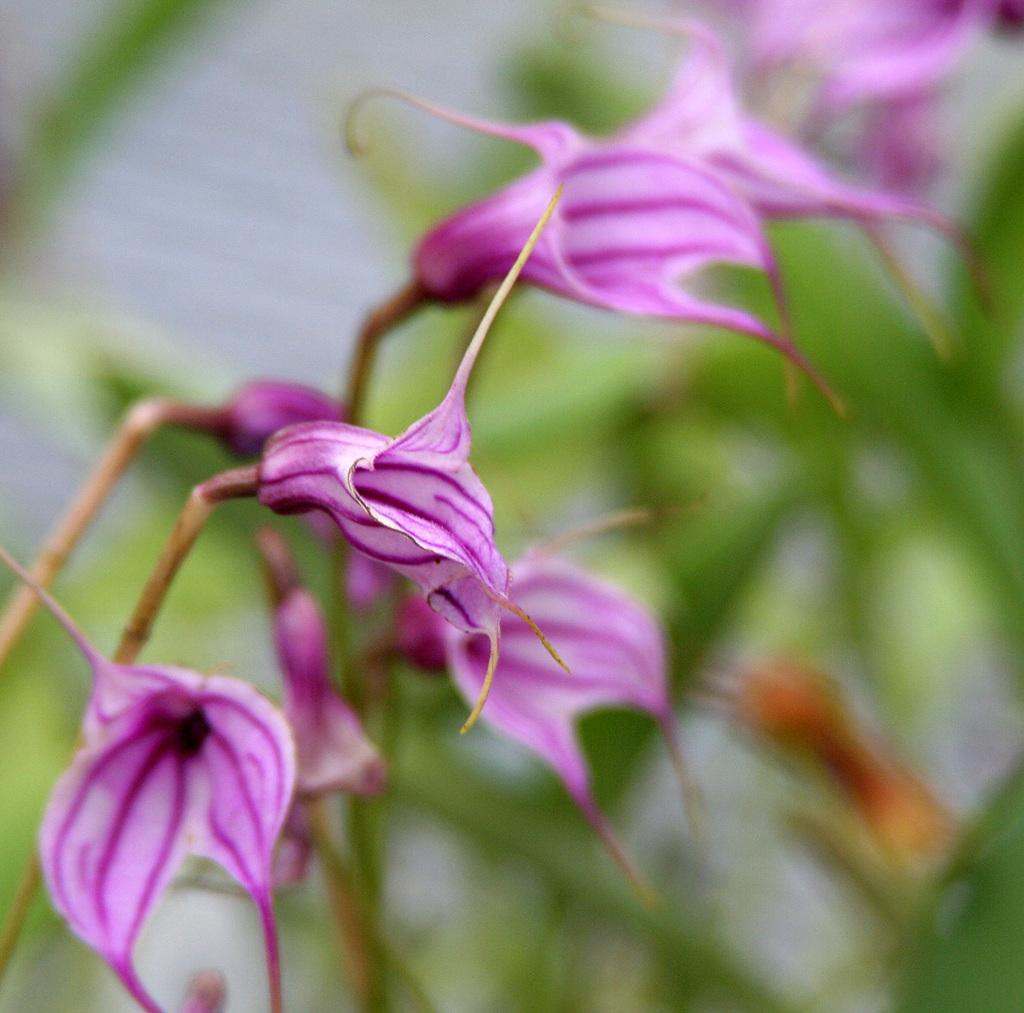What type of plants can be seen in the image? There are flowers in the image. What color are the flowers? The flowers are pink in color. What other natural element is present in the image? There is a tree in the image. What colors are the tree's leaves and trunk? The tree is green and brown in color. How would you describe the background of the image? The background of the image is blurry. Can you see any birds flying near the seashore in the image? There is no seashore or birds present in the image; it features flowers and a tree with a blurry background. 